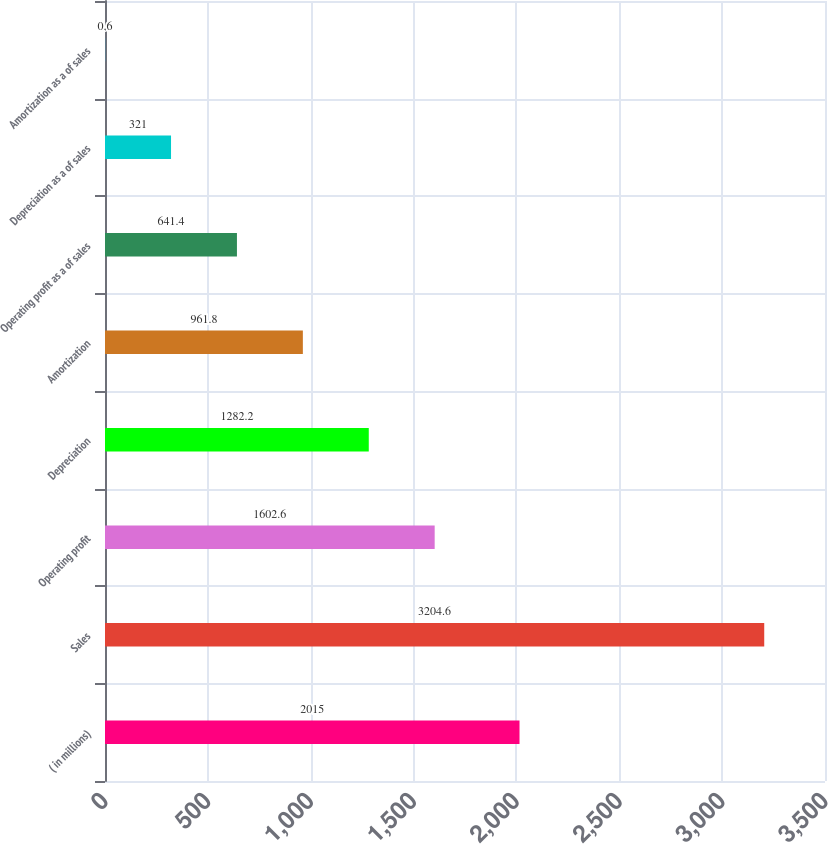<chart> <loc_0><loc_0><loc_500><loc_500><bar_chart><fcel>( in millions)<fcel>Sales<fcel>Operating profit<fcel>Depreciation<fcel>Amortization<fcel>Operating profit as a of sales<fcel>Depreciation as a of sales<fcel>Amortization as a of sales<nl><fcel>2015<fcel>3204.6<fcel>1602.6<fcel>1282.2<fcel>961.8<fcel>641.4<fcel>321<fcel>0.6<nl></chart> 